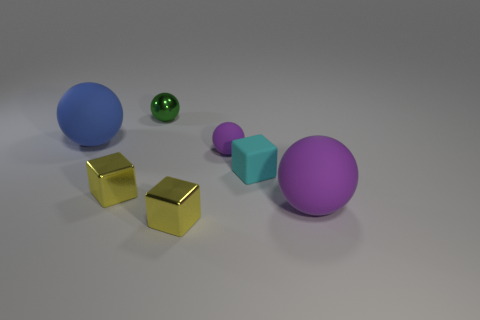Is the material of the tiny green sphere the same as the big purple ball right of the small purple ball?
Make the answer very short. No. Is the number of cyan things less than the number of purple balls?
Provide a succinct answer. Yes. Is there any other thing that has the same color as the tiny shiny sphere?
Ensure brevity in your answer.  No. The large purple object that is made of the same material as the small purple object is what shape?
Offer a terse response. Sphere. There is a tiny yellow metallic block behind the small yellow cube that is to the right of the tiny green metal ball; how many tiny cyan matte things are on the left side of it?
Ensure brevity in your answer.  0. What is the shape of the rubber object that is on the right side of the small purple rubber sphere and on the left side of the large purple ball?
Offer a very short reply. Cube. Are there fewer blue spheres on the right side of the green shiny object than large blue matte balls?
Provide a succinct answer. Yes. How many small objects are either rubber spheres or blue things?
Give a very brief answer. 1. The cyan cube has what size?
Provide a short and direct response. Small. How many large rubber things are behind the small cyan block?
Make the answer very short. 1. 